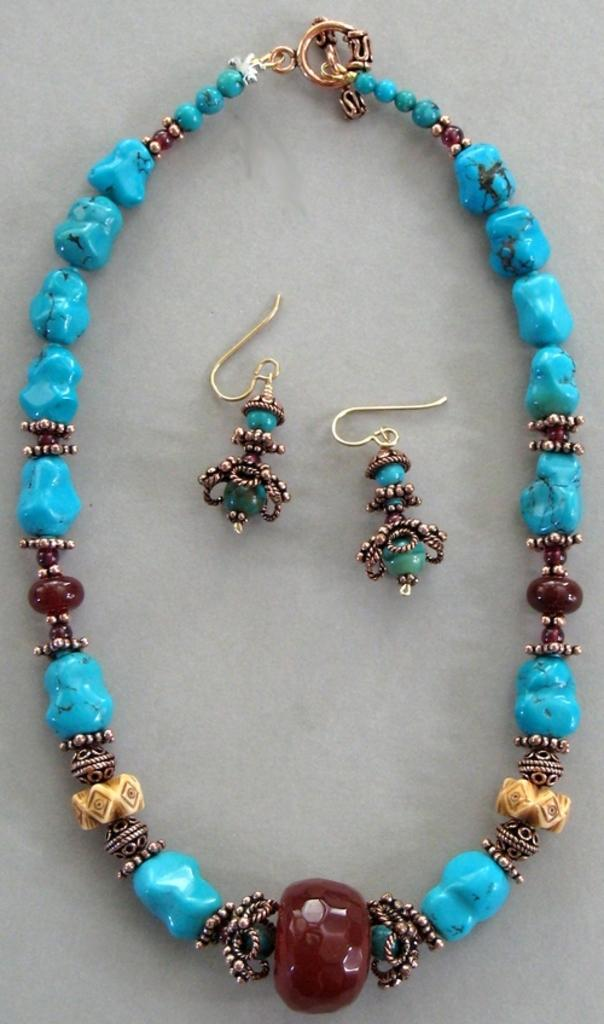What type of jewelry is present in the image? There is a necklace and earrings in the image. Can you describe the necklace in the image? The necklace has blue and maroon stones. How many bikes are parked next to the bed in the image? There are no bikes or beds present in the image; it only features a necklace and earrings. 